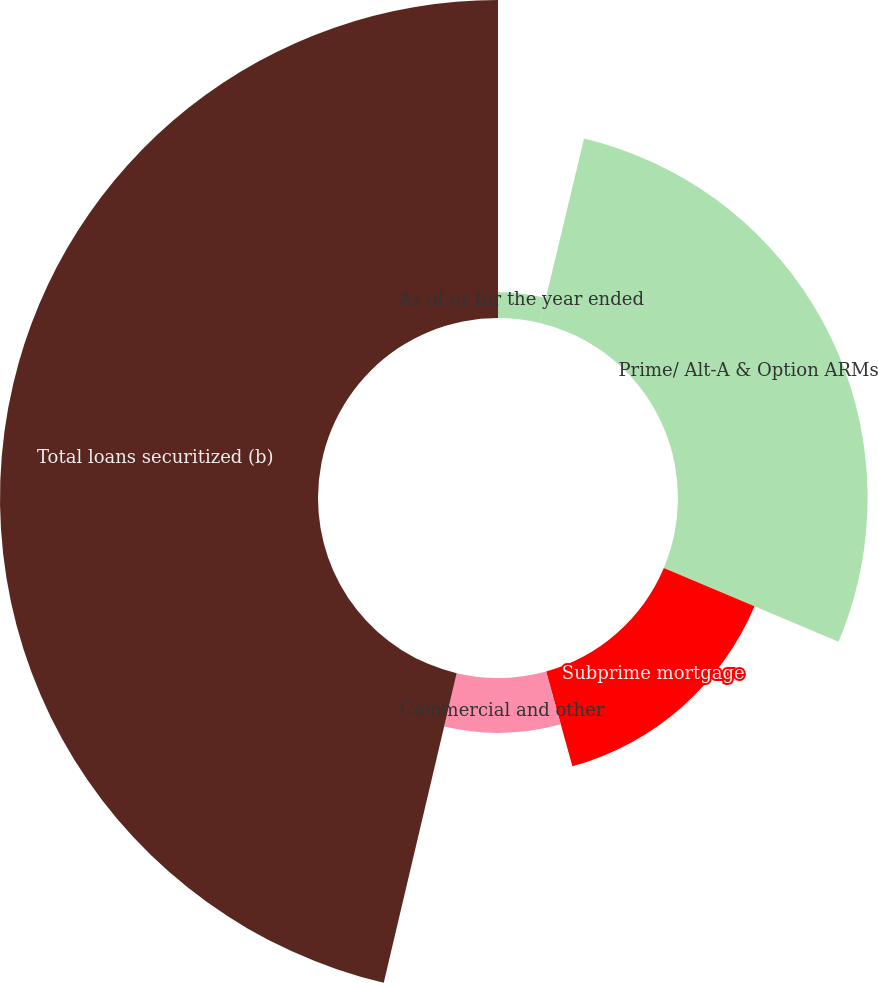<chart> <loc_0><loc_0><loc_500><loc_500><pie_chart><fcel>As of or for the year ended<fcel>Prime/ Alt-A & Option ARMs<fcel>Subprime mortgage<fcel>Commercial and other<fcel>Total loans securitized (b)<nl><fcel>3.74%<fcel>27.62%<fcel>14.34%<fcel>7.99%<fcel>46.32%<nl></chart> 